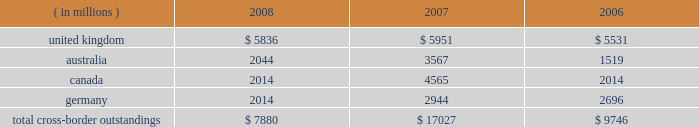Cross-border outstandings cross-border outstandings , as defined by bank regulatory rules , are amounts payable to state street by residents of foreign countries , regardless of the currency in which the claim is denominated , and local country claims in excess of local country obligations .
These cross-border outstandings consist primarily of deposits with banks , loan and lease financing and investment securities .
In addition to credit risk , cross-border outstandings have the risk that , as a result of political or economic conditions in a country , borrowers may be unable to meet their contractual repayment obligations of principal and/or interest when due because of the unavailability of , or restrictions on , foreign exchange needed by borrowers to repay their obligations .
Cross-border outstandings to countries in which we do business which amounted to at least 1% ( 1 % ) of our consolidated total assets were as follows as of december 31: .
The total cross-border outstandings presented in the table represented 5% ( 5 % ) , 12% ( 12 % ) and 9% ( 9 % ) of our consolidated total assets as of december 31 , 2008 , 2007 and 2006 , respectively .
Aggregate cross-border outstandings to countries which totaled between .75% ( .75 % ) and 1% ( 1 % ) of our consolidated total assets at december 31 , 2008 amounted to $ 3.45 billion ( canada and germany ) .
There were no cross-border outstandings to countries which totaled between .75% ( .75 % ) and 1% ( 1 % ) of our consolidated total assets as of december 31 , 2007 .
Aggregate cross-border outstandings to countries which totaled between .75% ( .75 % ) and 1% ( 1 % ) of our consolidated total assets at december 31 , 2006 amounted to $ 1.05 billion ( canada ) .
Capital regulatory and economic capital management both use key metrics evaluated by management to assess whether our actual level of capital is commensurate with our risk profile , is in compliance with all regulatory requirements , and is sufficient to provide us with the financial flexibility to undertake future strategic business initiatives .
Regulatory capital our objective with respect to regulatory capital management is to maintain a strong capital base in order to provide financial flexibility for our business needs , including funding corporate growth and supporting customers 2019 cash management needs , and to provide protection against loss to depositors and creditors .
We strive to maintain an optimal level of capital , commensurate with our risk profile , on which an attractive return to shareholders will be realized over both the short and long term , while protecting our obligations to depositors and creditors and satisfying regulatory requirements .
Our capital management process focuses on our risk exposures , our capital position relative to our peers , regulatory capital requirements and the evaluations of the major independent credit rating agencies that assign ratings to our public debt .
Our capital committee , working in conjunction with our asset and liability committee , referred to as alco , oversees the management of regulatory capital , and is responsible for ensuring capital adequacy with respect to regulatory requirements , internal targets and the expectations of the major independent credit rating agencies .
The primary regulator of both state street and state street bank for regulatory capital purposes is the federal reserve .
Both state street and state street bank are subject to the minimum capital requirements established by the federal reserve and defined in the federal deposit insurance corporation improvement act .
What percent increase did the united kingdom cross border outstandings experience between 2006 and 2008? 
Computations: ((5836 - 5531) / 5531)
Answer: 0.05514. 